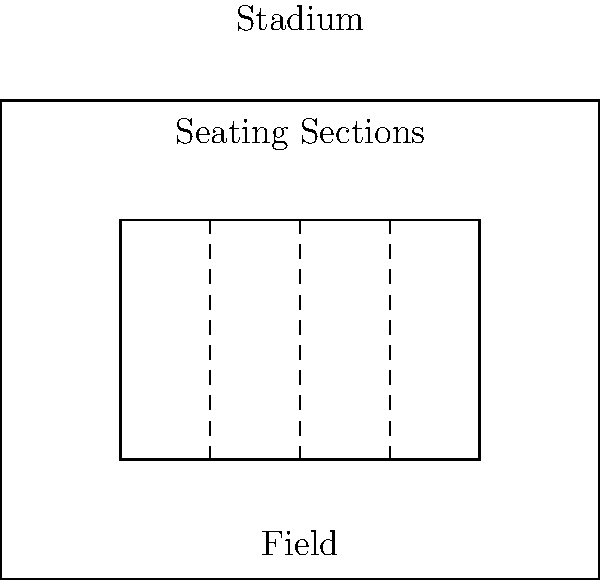As the enthusiastic local sports columnist covering JCB Bhilai Brothers FC, you've been asked to analyze the stadium's seating arrangement. The rectangular stadium has dimensions of 100m x 80m, with a central playing field of 80m x 60m. To maximize capacity, the stadium management is considering dividing the remaining space into equal-width seating sections. If each section requires a minimum width of 3m for comfortable seating and proper evacuation, what is the maximum number of seating sections that can be created along the length of the stadium? Let's approach this step-by-step:

1) First, we need to calculate the available space for seating sections:
   - Stadium length = 100m
   - Field length = 80m
   - Available space = 100m - 80m = 20m

2) This 20m of available space is divided equally on both sides of the field:
   - Space on each side = 20m ÷ 2 = 10m

3) Now, we need to determine how many 3m sections can fit within this 10m space:
   - Number of sections = Available space ÷ Minimum section width
   - Number of sections = 10m ÷ 3m = 3.33

4) Since we can't have a fractional number of sections, we round down to the nearest whole number:
   - Maximum number of sections on each side = 3

5) As this is true for both sides of the field, we multiply by 2:
   - Total maximum number of sections = 3 × 2 = 6

Therefore, the maximum number of seating sections that can be created along the length of the stadium is 6.
Answer: 6 sections 